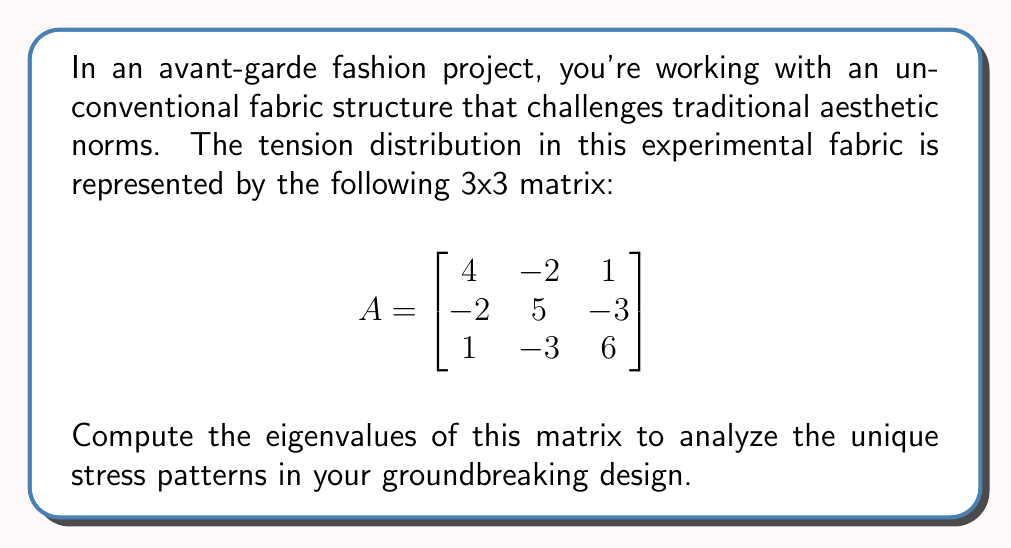Teach me how to tackle this problem. To find the eigenvalues of matrix A, we need to solve the characteristic equation:

$$\det(A - \lambda I) = 0$$

Where $\lambda$ represents the eigenvalues and I is the 3x3 identity matrix.

Step 1: Set up the characteristic equation
$$\det\begin{bmatrix}
4-\lambda & -2 & 1 \\
-2 & 5-\lambda & -3 \\
1 & -3 & 6-\lambda
\end{bmatrix} = 0$$

Step 2: Expand the determinant
$$(4-\lambda)[(5-\lambda)(6-\lambda) - 9] + (-2)[(-2)(6-\lambda) - 1] + 1[(-2)(-3) - (5-\lambda)] = 0$$

Step 3: Simplify
$$(4-\lambda)[(30-11\lambda+\lambda^2) - 9] + (-2)[-12+2\lambda - 1] + 1[6 - (5-\lambda)] = 0$$
$$(4-\lambda)(21-11\lambda+\lambda^2) + (-2)(-13+2\lambda) + (1+\lambda) = 0$$

Step 4: Expand and collect terms
$$84-44\lambda+4\lambda^2 - 21\lambda+11\lambda^2-\lambda^3 + 26-4\lambda + 1 + \lambda = 0$$
$$-\lambda^3 + 15\lambda^2 - 68\lambda + 111 = 0$$

Step 5: Factor the cubic equation
$$-(\lambda - 3)(\lambda - 6)(\lambda - 6) = 0$$

Step 6: Solve for $\lambda$
The eigenvalues are the solutions to this equation:
$\lambda_1 = 3$
$\lambda_2 = 6$ (with algebraic multiplicity 2)

These eigenvalues represent the principal stresses in your unconventional fabric structure, revealing the unique tension patterns that defy traditional fabric behavior.
Answer: The eigenvalues of the matrix are:
$\lambda_1 = 3$
$\lambda_2 = 6$ (with algebraic multiplicity 2) 